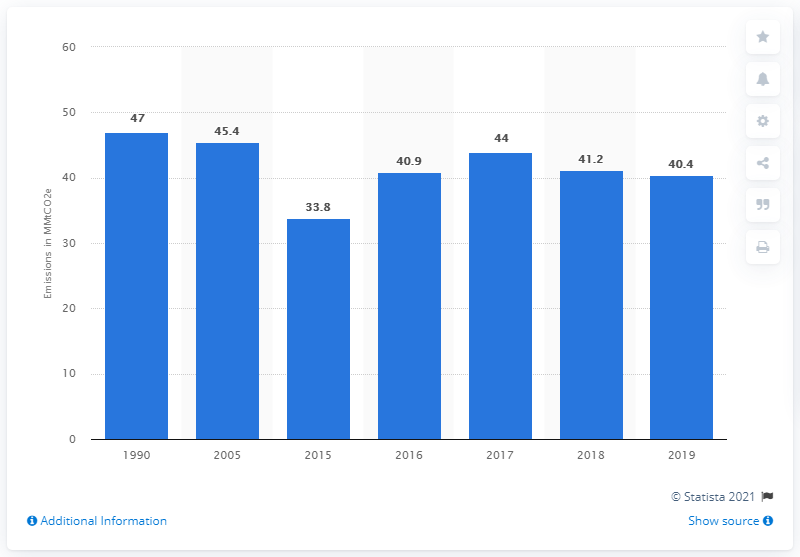Point out several critical features in this image. In 2019, an estimated 40.4 million metric tons of carbon dioxide equivalent were released from ships and boats in the United States. 